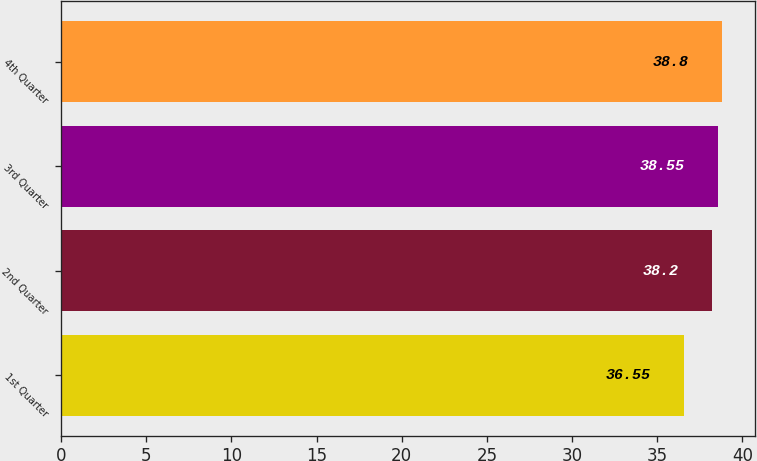Convert chart to OTSL. <chart><loc_0><loc_0><loc_500><loc_500><bar_chart><fcel>1st Quarter<fcel>2nd Quarter<fcel>3rd Quarter<fcel>4th Quarter<nl><fcel>36.55<fcel>38.2<fcel>38.55<fcel>38.8<nl></chart> 